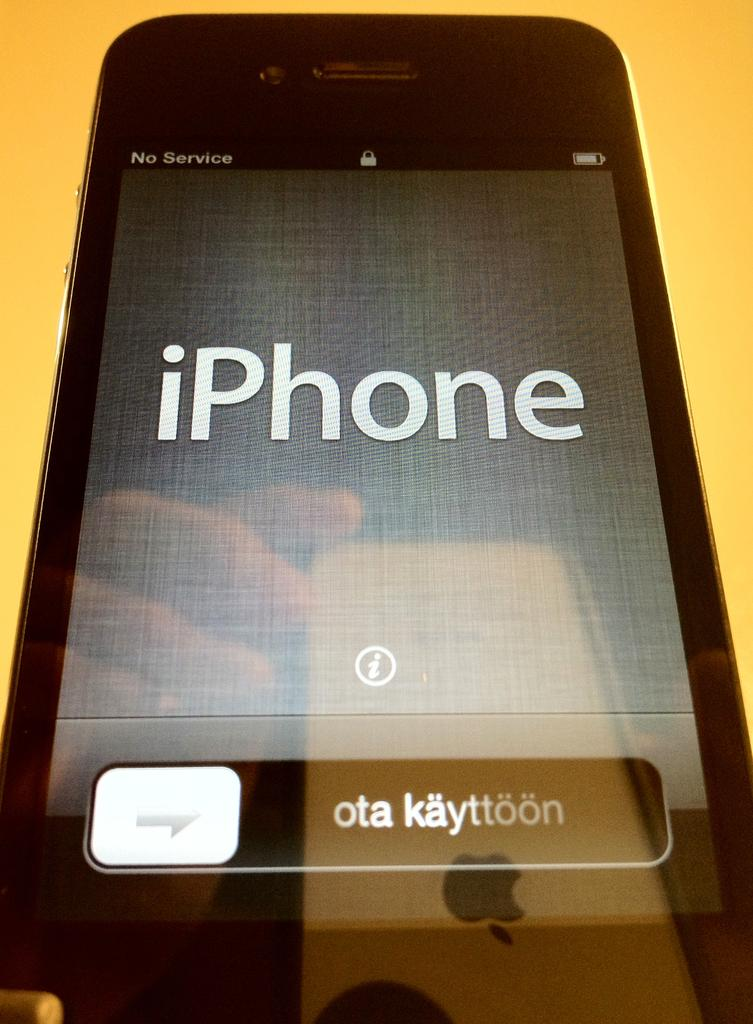<image>
Render a clear and concise summary of the photo. A locked iPhone with a plain gray background. 